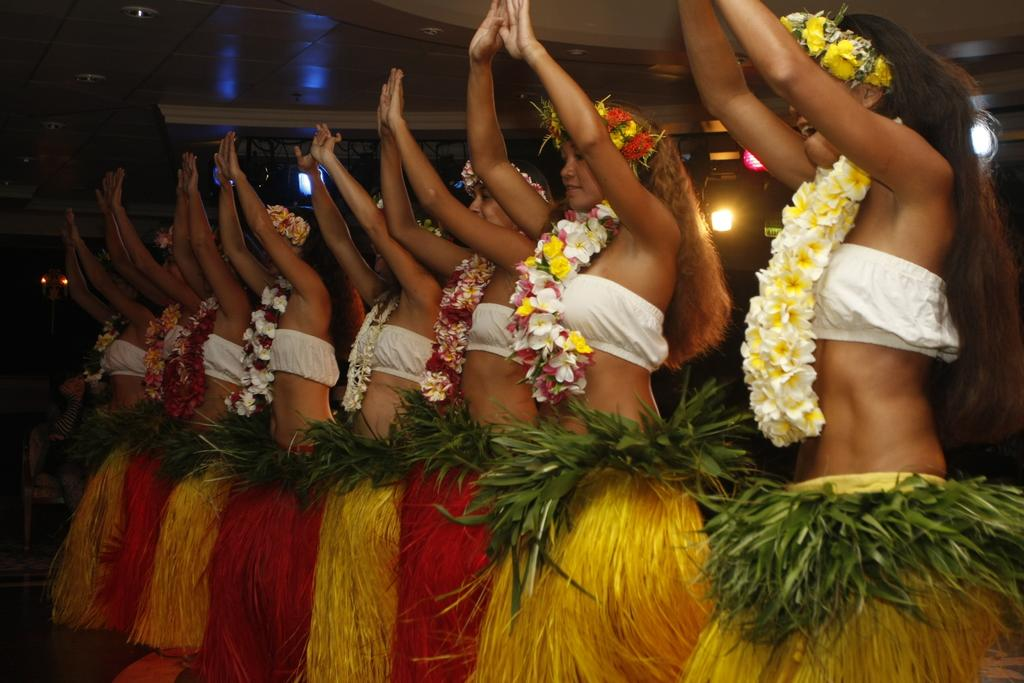What are the women in the image wearing? The women in the image are wearing costumes. How are the women positioned in the image? The women are standing on the floor in a row. What can be seen in the background of the image? There are iron grills and electric lights in the background of the image. Can you describe the person in the background of the image? There is a person sitting on a chair in the background of the image. What type of jeans is the secretary wearing in the image? There is no secretary or jeans present in the image. How many visitors can be seen in the image? There are no visitors present in the image. 